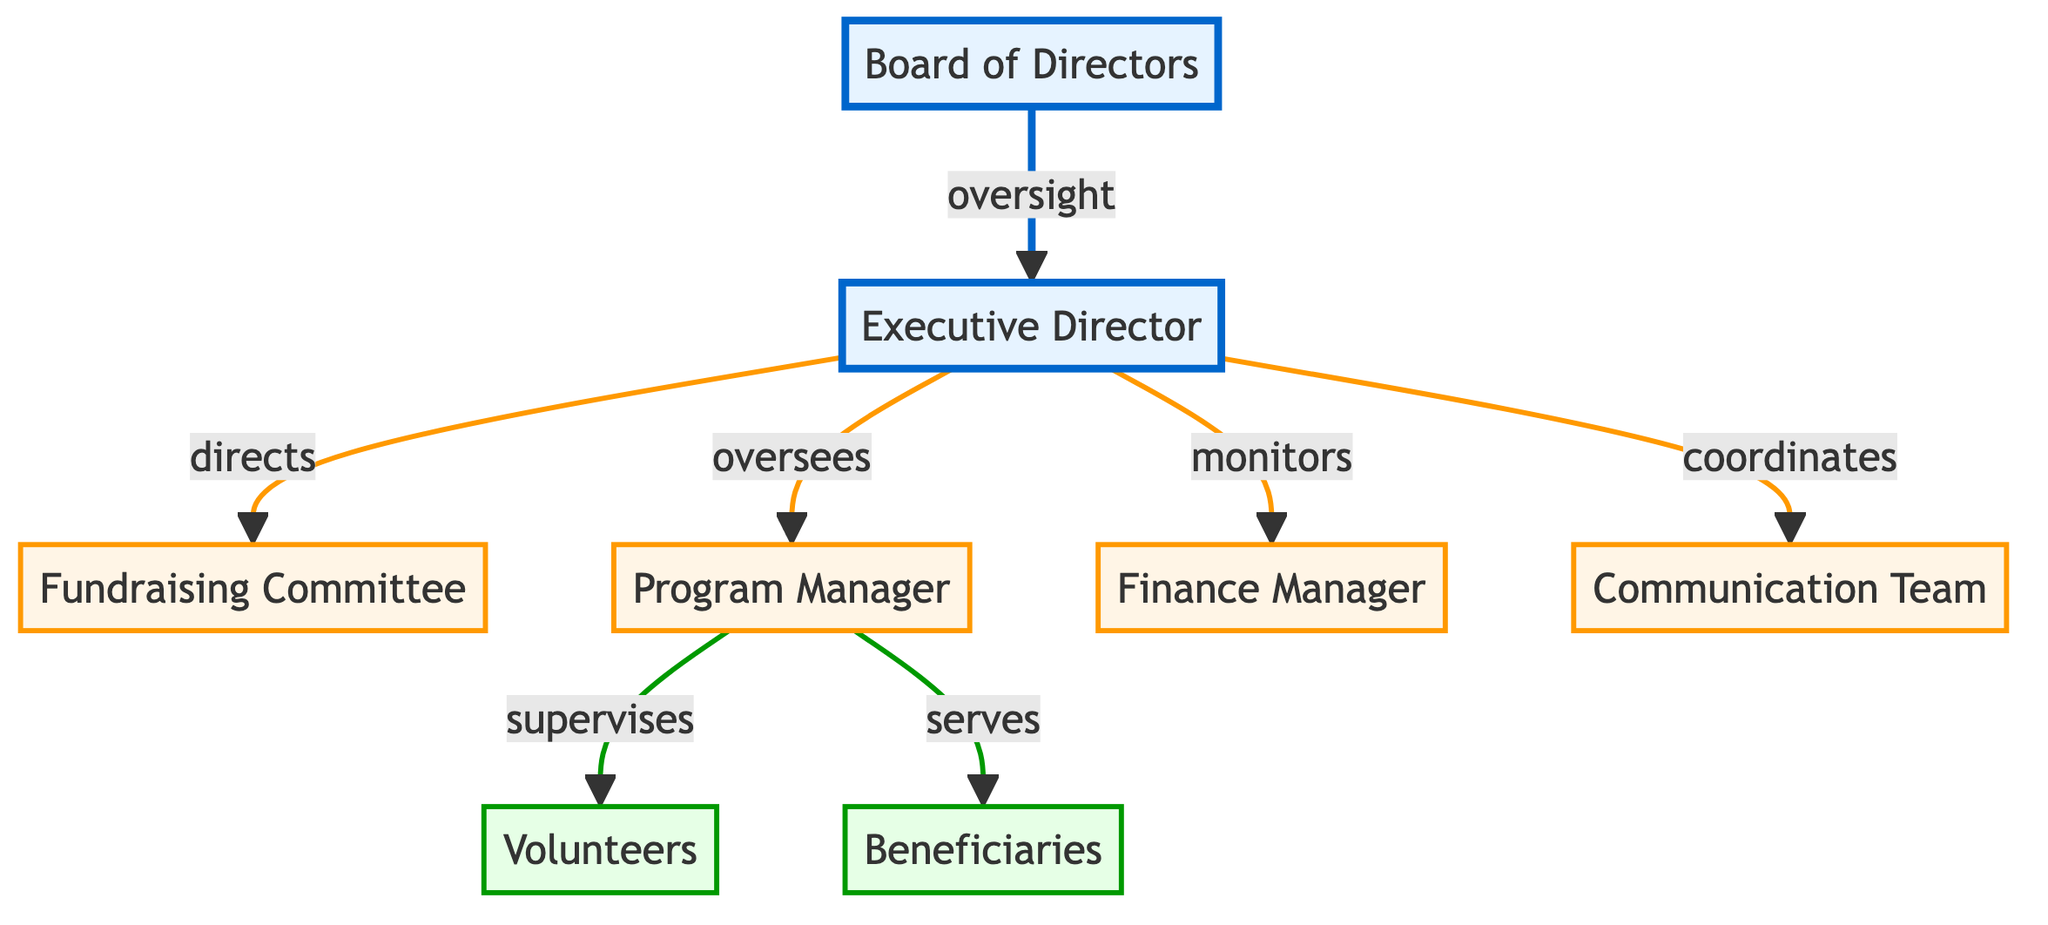What is the topmost role in the organizational structure? The diagram identifies the "Board of Directors" as the topmost role, as it is at the highest position and is colored to indicate its prominence in the structure.
Answer: Board of Directors How many committees are directly under the Executive Director? Tracing the arrows from the "Executive Director" reveals there are four entities directly connected: "Fundraising Committee," "Program Manager," "Finance Manager," and "Communication Team."
Answer: Four Who supervises the volunteers? The "Program Manager" is shown as the role that directly supervises the "Volunteers" in the diagram, indicated by an arrow from "Program Manager" to "Volunteers."
Answer: Program Manager Who reports directly to the Executive Director? The roles that report to the "Executive Director," identified by arrows leading from it, are "Fundraising Committee," "Program Manager," "Finance Manager," and "Communication Team." This confirms that four distinct entities report to the Executive Director.
Answer: Fundraising Committee, Program Manager, Finance Manager, Communication Team What term describes the relationship between the Board of Directors and the Executive Director? The term "oversight" is explicitly described on the arrow connecting the "Board of Directors" to the "Executive Director," indicating the type of relationship that exists between these two roles.
Answer: Oversight What role serves the beneficiaries? Following the flow, the "Program Manager" is indicated to serve the "Beneficiaries," as shown by the directional arrow leading from "Program Manager" to "Beneficiaries."
Answer: Program Manager How many entities are at the bottom of the structure? The diagram indicates that there are two entities at the bottom: "Volunteers" and "Beneficiaries," visualized in a lower tier, thus confirming the total number.
Answer: Two What color represents the Finance Manager? In the diagram, the "Finance Manager" is portrayed in a mid-tier color scheme, represented with an orange fill color.
Answer: Orange Which team is coordinated by the Executive Director? The "Communication Team" is directly connected by an arrow from the "Executive Director," indicating that this team is coordinated by the Executive Director.
Answer: Communication Team 